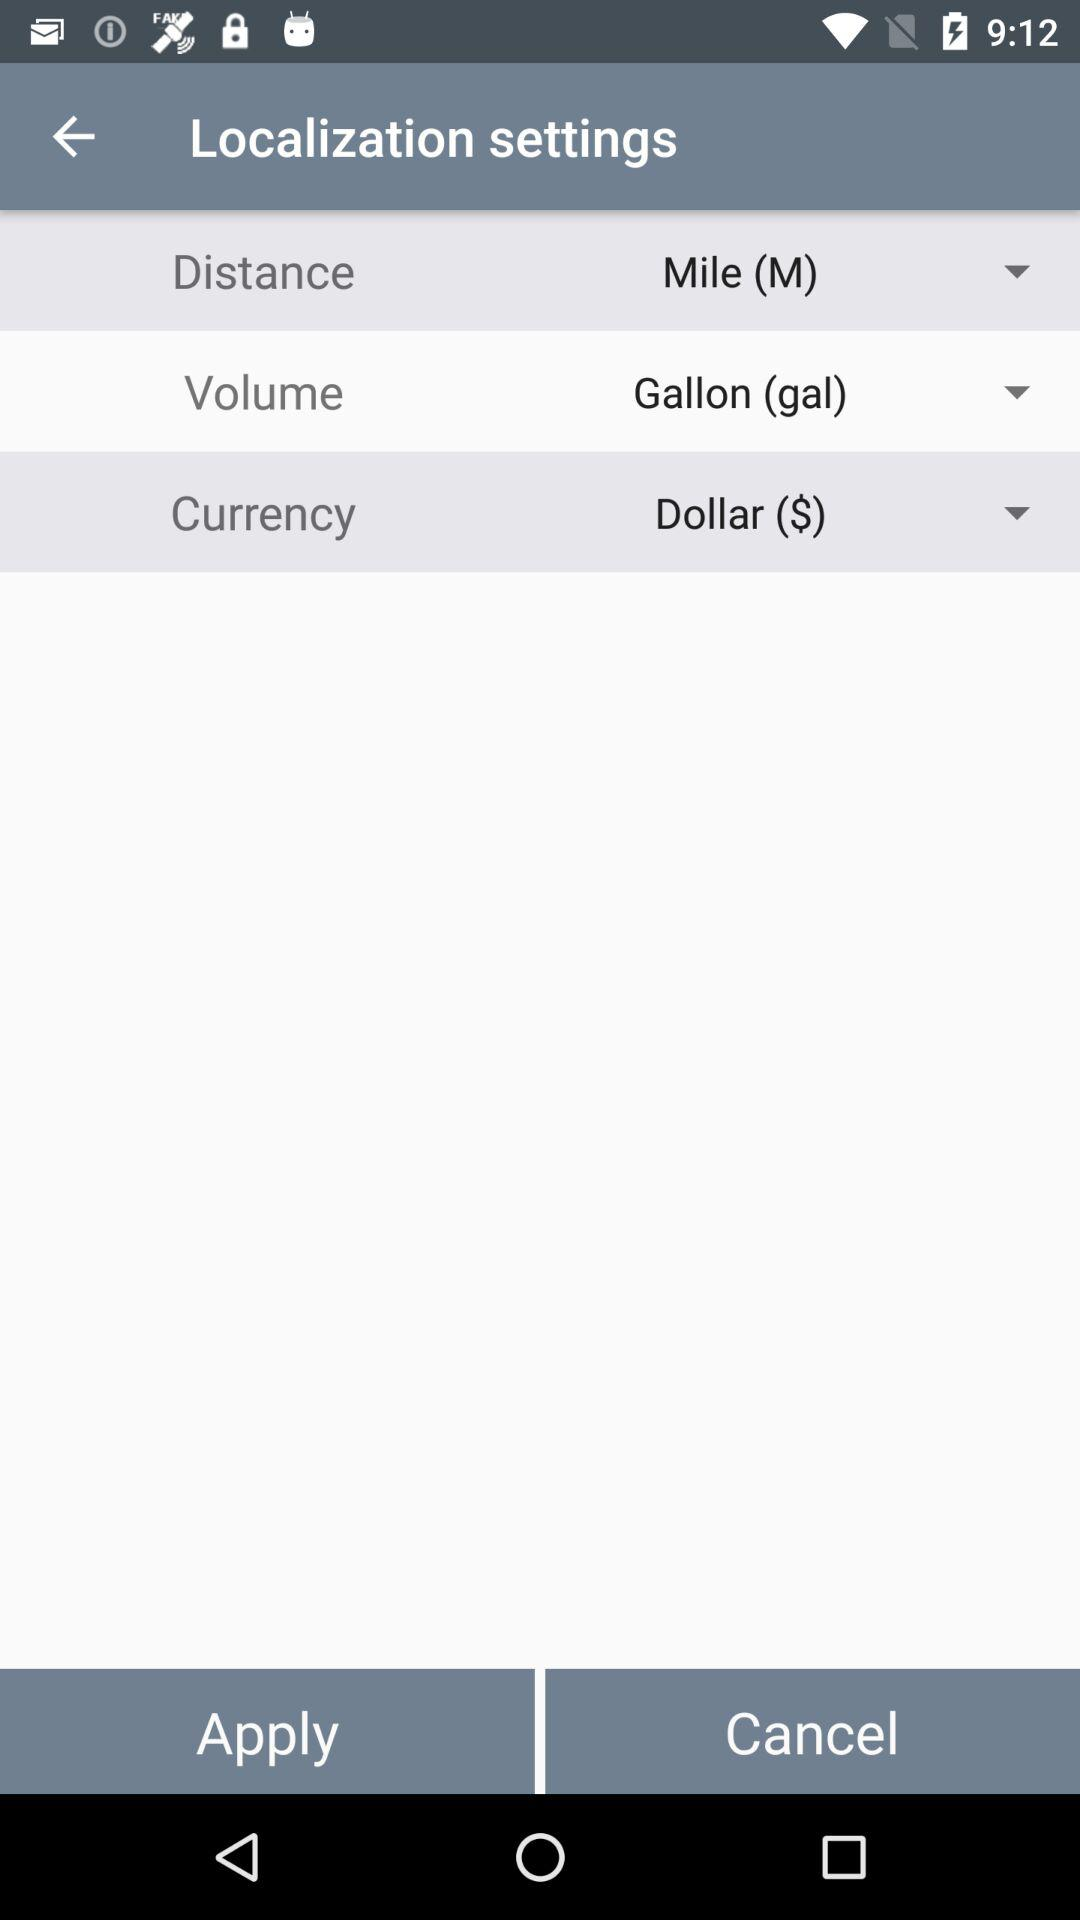What unit of volume has been chosen? The chosen unit of volume is the gallon (gal). 